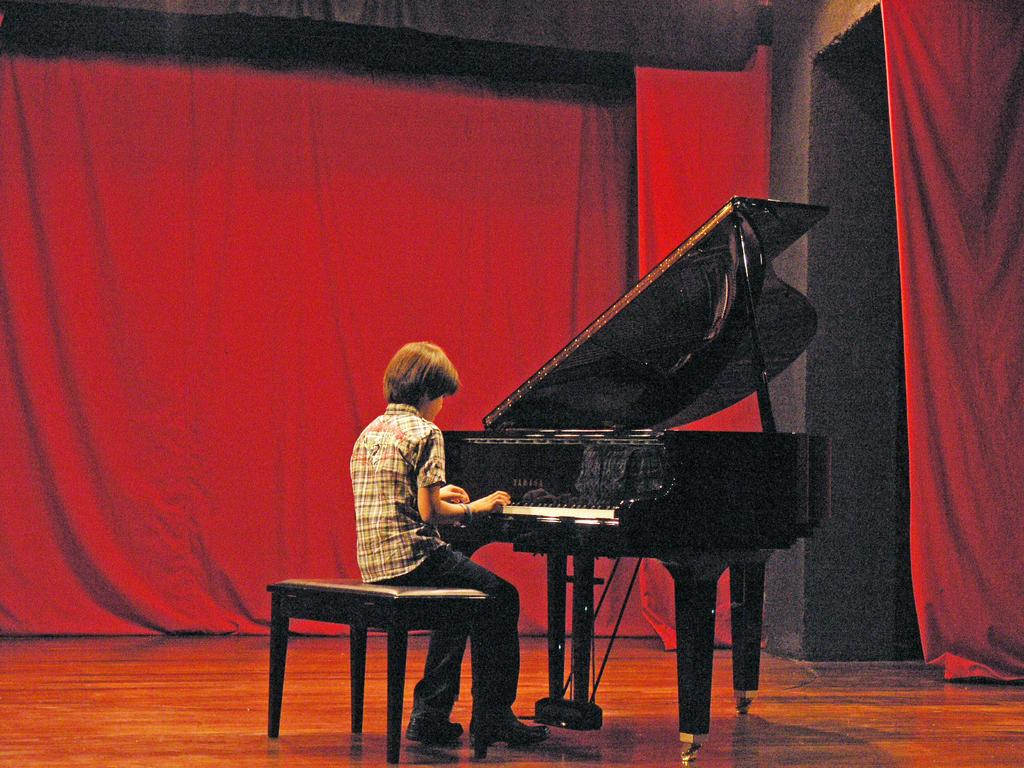Who is the main subject in the image? There is a boy in the image. What is the boy doing in the image? The boy is sitting on a chair and playing a piano. What can be seen below the boy in the image? There is a floor visible in the image. What type of decoration is present in the image? There is a red curtain in the image. Where is the table located in the image? There is no table present in the image. What type of sheet is covering the piano in the image? There is no sheet covering the piano in the image; the boy is playing it directly. 